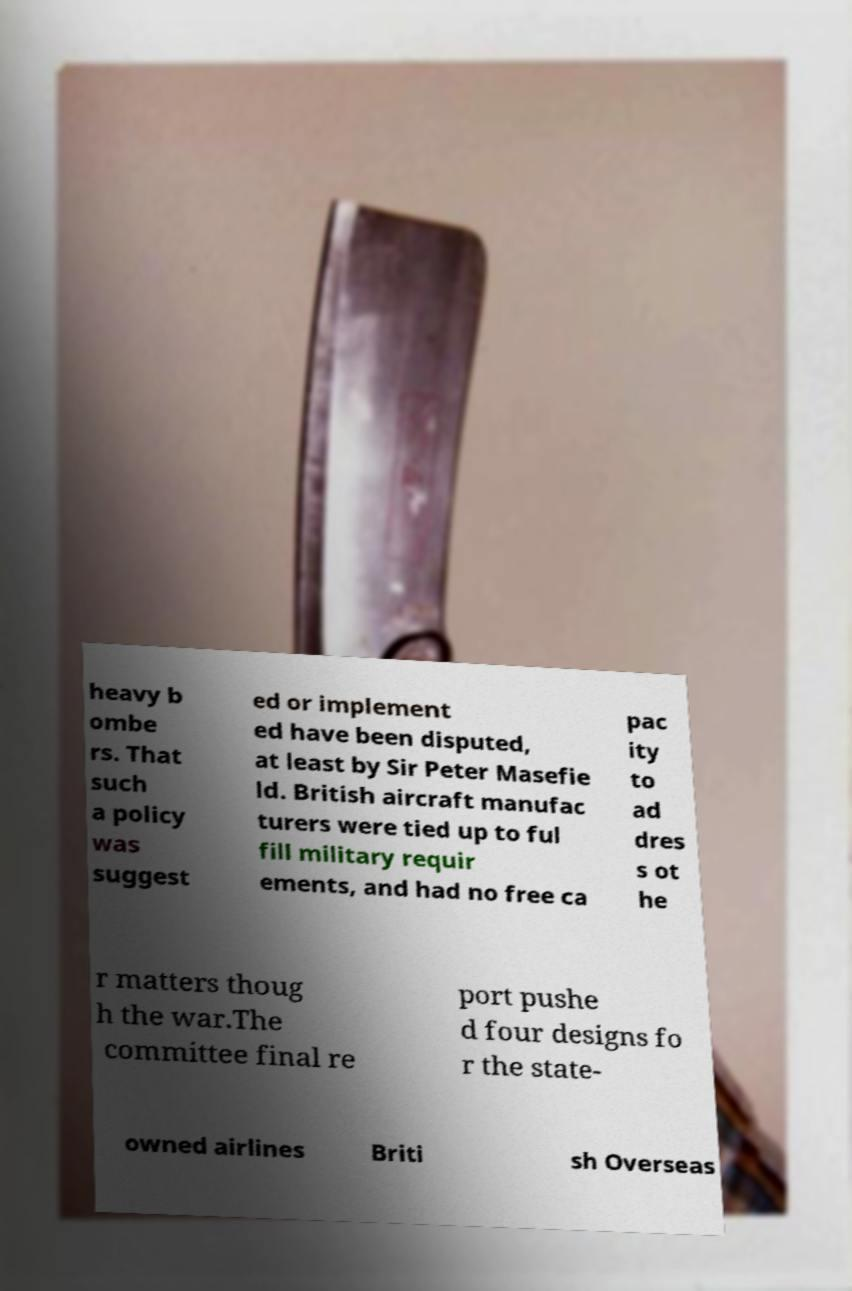I need the written content from this picture converted into text. Can you do that? heavy b ombe rs. That such a policy was suggest ed or implement ed have been disputed, at least by Sir Peter Masefie ld. British aircraft manufac turers were tied up to ful fill military requir ements, and had no free ca pac ity to ad dres s ot he r matters thoug h the war.The committee final re port pushe d four designs fo r the state- owned airlines Briti sh Overseas 